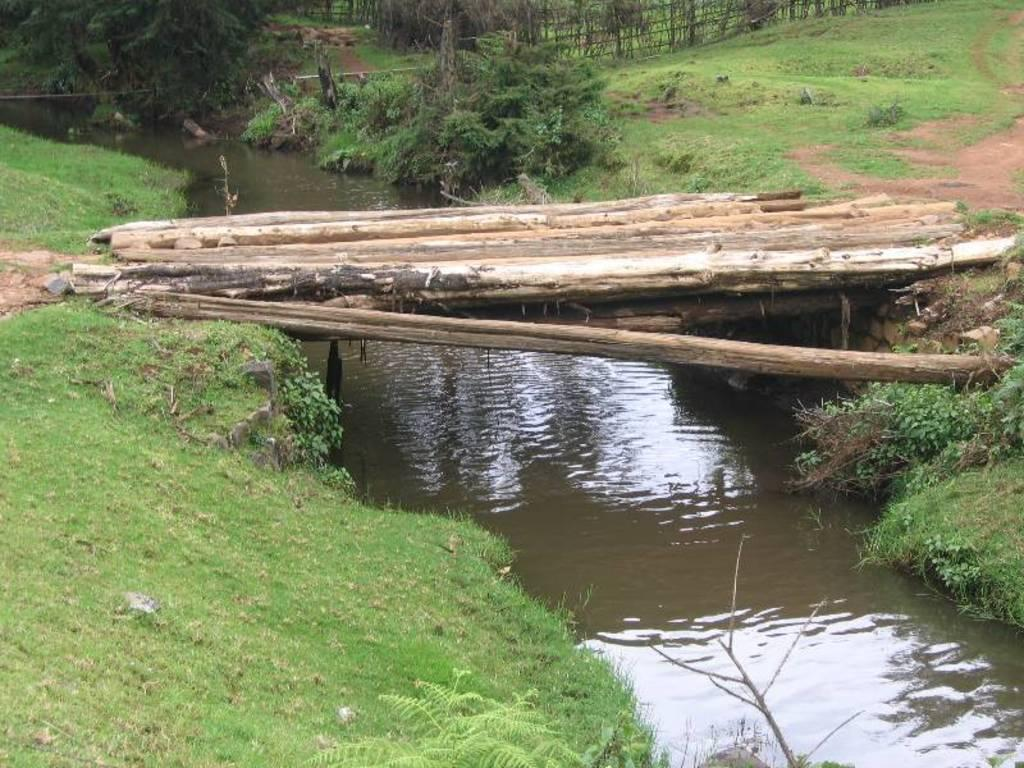What is the main feature in the middle of the image? There is a canal in the middle of the image. What is above the canal? There is a bridge above the canal. What type of landscape surrounds the canal? There is grassland on either side of the canal. Where is the pan located in the image? There is no pan present in the image. How many brothers can be seen in the image? There are no people, let alone brothers, depicted in the image. 